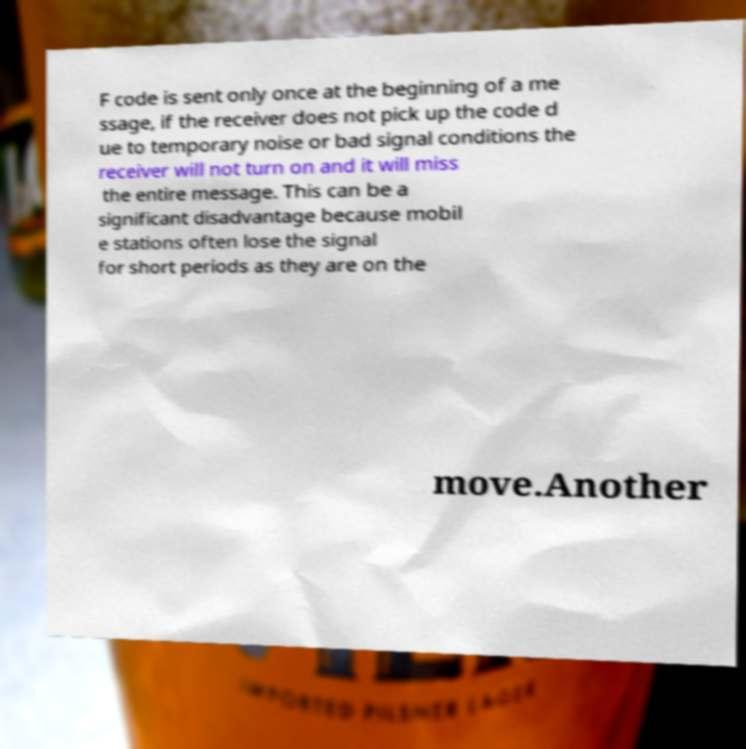Please read and relay the text visible in this image. What does it say? F code is sent only once at the beginning of a me ssage, if the receiver does not pick up the code d ue to temporary noise or bad signal conditions the receiver will not turn on and it will miss the entire message. This can be a significant disadvantage because mobil e stations often lose the signal for short periods as they are on the move.Another 